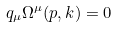Convert formula to latex. <formula><loc_0><loc_0><loc_500><loc_500>q _ { \mu } \Omega ^ { \mu } ( p , k ) = 0</formula> 